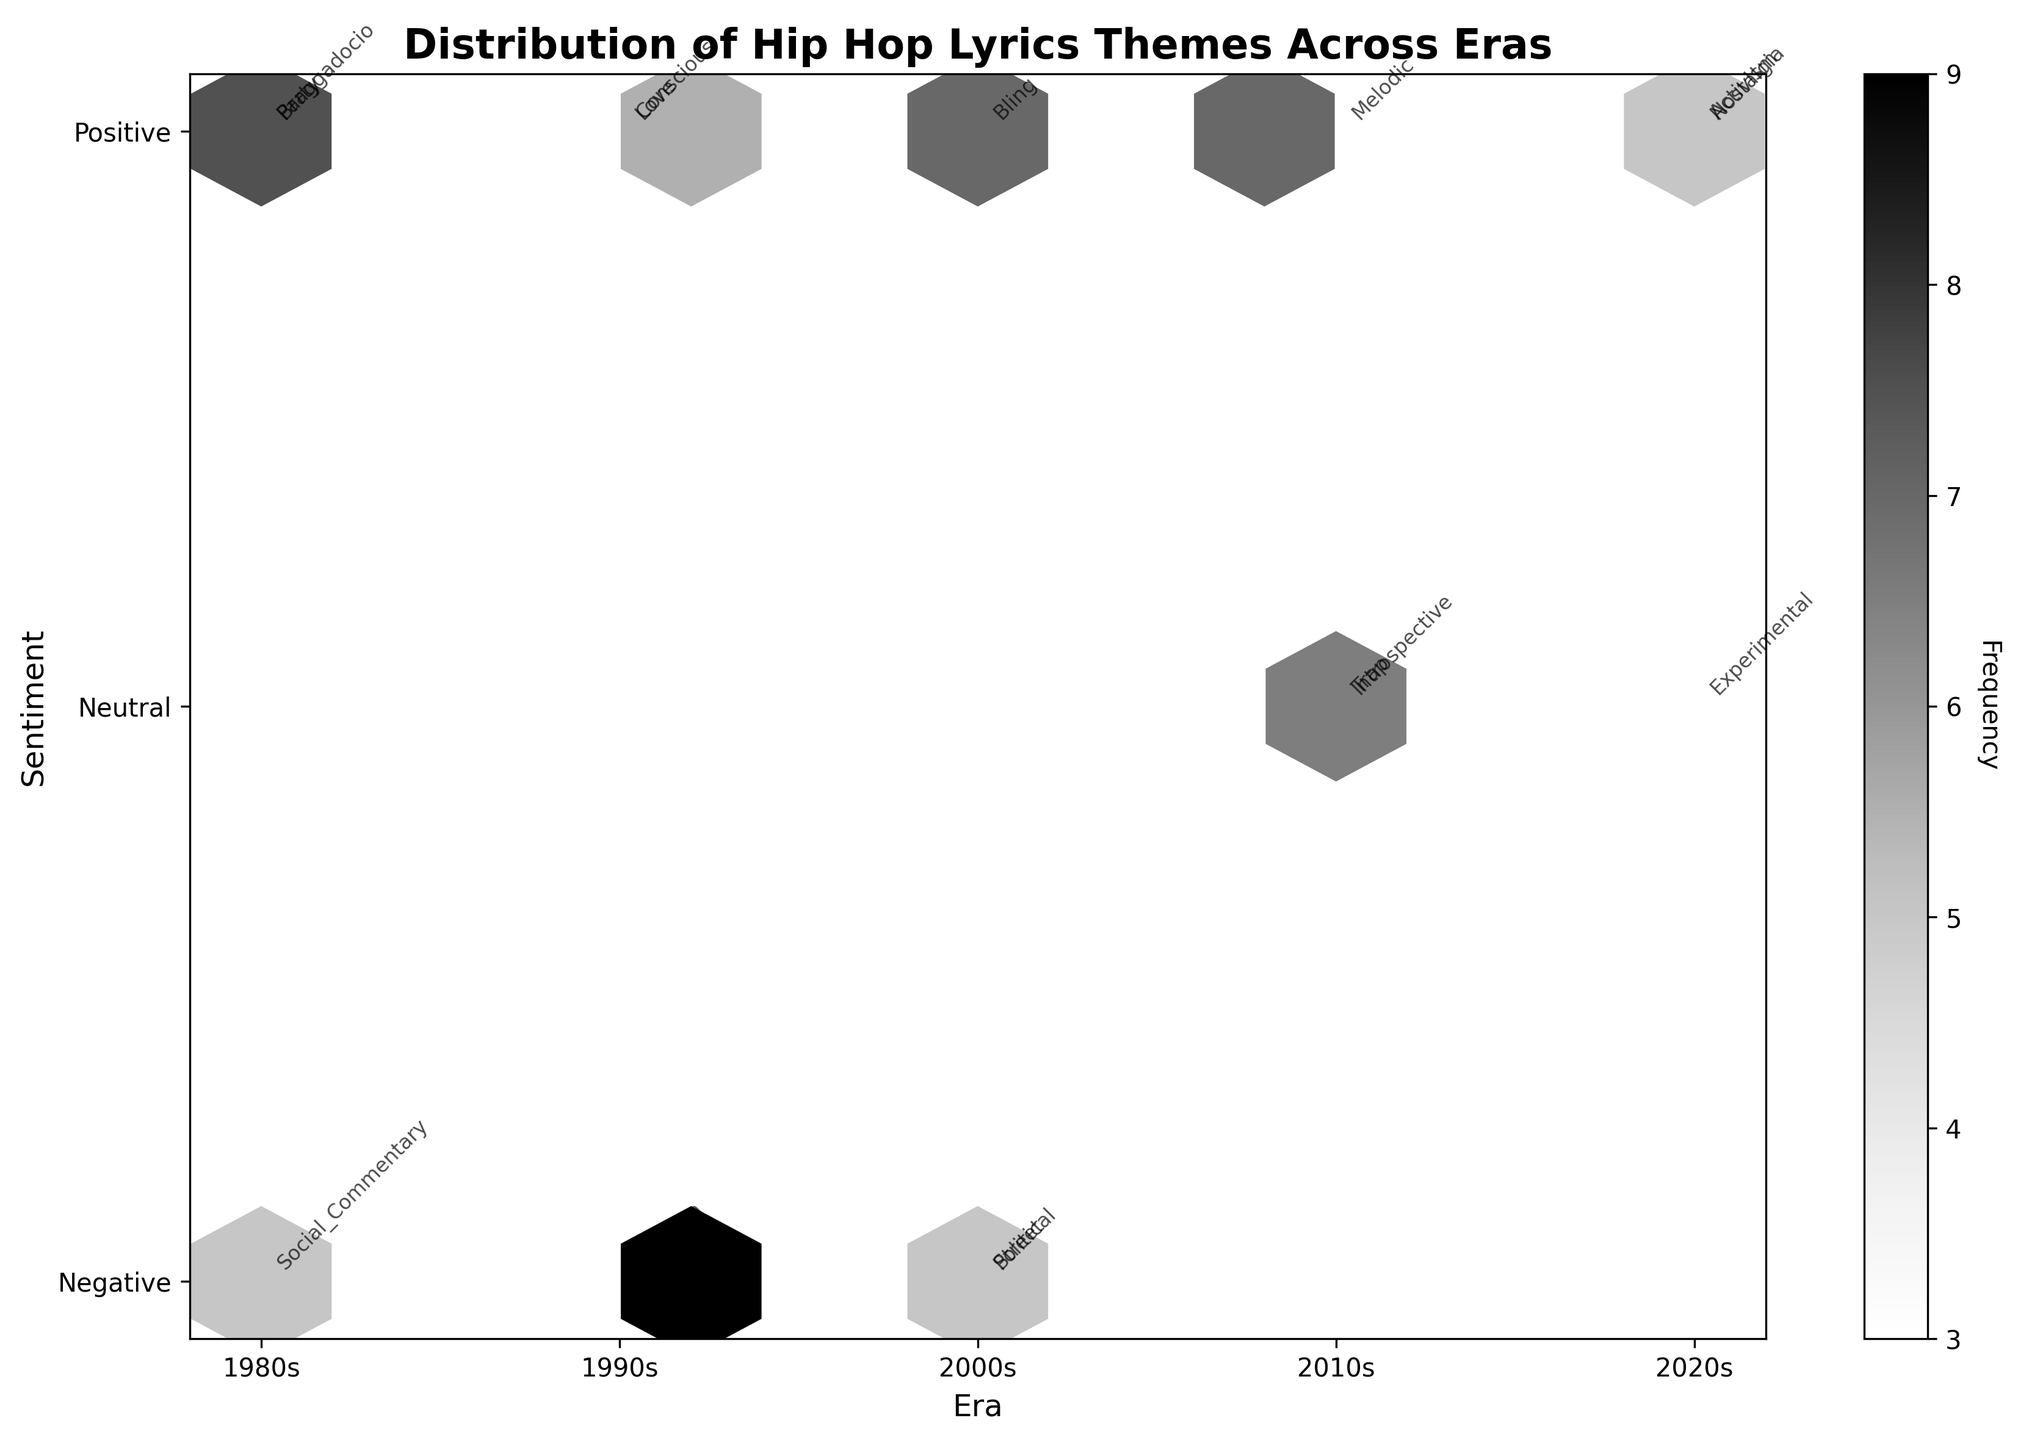What is the title of the plot? The title is prominently displayed at the top of the plot. The title reads "Distribution of Hip Hop Lyrics Themes Across Eras".
Answer: Distribution of Hip Hop Lyrics Themes Across Eras How many eras are represented on the x-axis? The x-axis has labels indicating different eras: 1980s, 1990s, 2000s, 2010s, and 2020s. By counting these labels, we can see that there are five eras represented.
Answer: Five Which era has the highest frequency of themes with positive sentiment? We need to look at the hexagons positioned above the x-axis that correspond to positive sentiment and then identify which hexagon has the highest frequency. The denser hexbin for positive sentiment is located at the x-coordinate for the 2000s.
Answer: 2000s How does the frequency of themes in the '1980s' compare to the '2010s’? Compare the density of hexagons for the two eras. The 1980s have fewer and less dense hexagons compared to the 2010s, indicating a lower frequency.
Answer: 1980s have lower frequency than 2010s What is the range of sentiments reflected in the 2020s? The y-axis represents sentiment. By observing the hexagons along the x-axis label '2020s', we see hexagons from positive through to neutral, but none in the negative.
Answer: Positive to neutral Which subject matter falls under the 'Negative' sentiment in the 1990s? By identifying the hexagons in the 1990s associated with the negative sentiment, we notice annotations for Gangsta (Violence).
Answer: Gangsta (Violence) What era shows the most diverse range of sentiments? We need to evaluate which era has hexagons spread across the widest range of sentiments on the y-axis. The 2010s display hexagons that cover negative, neutral, and mixed sentiments.
Answer: 2010s Do themes in the 2000s generally have a positive or negative sentiment? By observing the predominant position of hexagons in the 2000s on the y-axis, which is mostly clustered above the positive sentiment mark, it is clear they are generally positive.
Answer: Positive What is the frequency of 'Social_Justice' themes in the 2020s? Locate the annotation for 'Activism' within the 2020s era and check its frequency, which is indicated in the data table as 6.
Answer: 6 How many themes in the 1980s have a positive sentiment? Identify the hexagons in the 1980s era above the positive sentiment line and count them, noting themes like Party, Braggadocio. There are two hexagons.
Answer: Two 